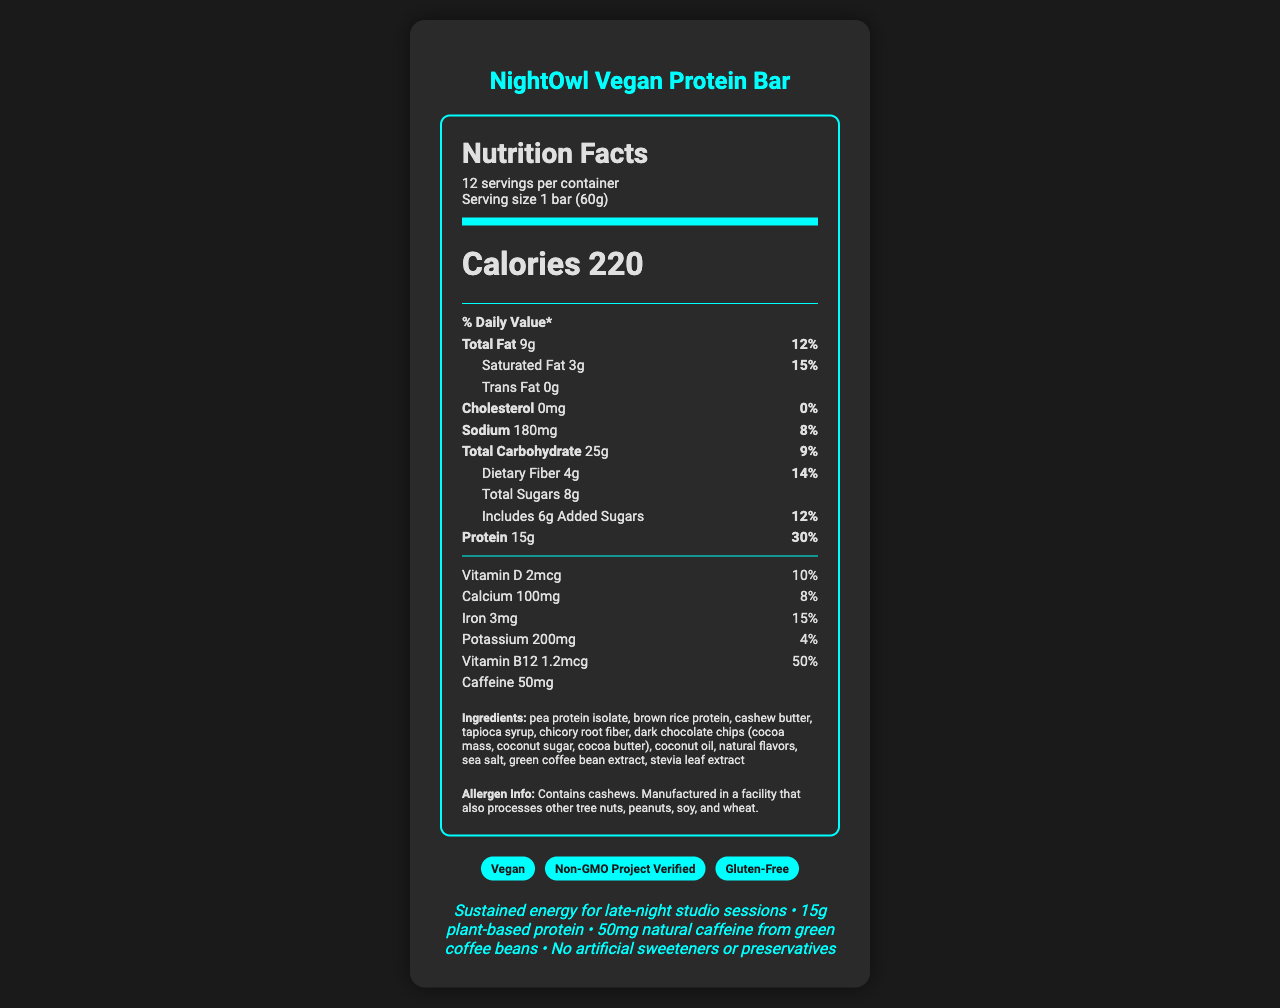what is the serving size of the NightOwl Vegan Protein Bar? The serving size information is located at the top of the nutrition facts label under the section titled "Serving size."
Answer: 1 bar (60g) how many servings are there per container? The label indicates “12 servings per container” near the top beneath the product name.
Answer: 12 how many grams of protein are in each bar? The protein content per serving is listed in the protein section of the nutrition facts with the amount “15g” and a daily value percentage of 30%.
Answer: 15g what is the daily value percentage of Vitamin B12 in each bar? You can find the daily value percentage of Vitamin B12 under its amount listed as “1.2mcg” and “50%”.
Answer: 50% which ingredient in the NightOwl Vegan Protein Bar provides natural caffeine? The ingredients list includes "green coffee bean extract" which is known to be a source of natural caffeine.
Answer: Green coffee bean extract how many calories are in one serving of the NightOwl Vegan Protein Bar? The calorie count is prominently displayed in large font under the header "Nutrition Facts" as “Calories 220”.
Answer: 220 what are the certifications of the NightOwl Vegan Protein Bar? A. USDA Organic, Non-GMO, Gluten-Free B. Vegan, Non-GMO Project Verified, Gluten-Free C. Vegan, Fair Trade, Gluten-Free D. Vegan, Non-GMO, USDA Organic The certifications are listed towards the bottom of the label in blue badges as "Vegan," "Non-GMO Project Verified," and "Gluten-Free".
Answer: B. Vegan, Non-GMO Project Verified, Gluten-Free what is the daily value percentage of saturated fat per serving? A. 10% B. 15% C. 20% D. 25% The daily value percentage for saturated fat is listed in the component section as “3g” with “15%” daily value.
Answer: B. 15% does the bar contain any artificial sweeteners or preservatives? One of the marketing claims says "No artificial sweeteners or preservatives."
Answer: No does the NightOwl Vegan Protein Bar contain any trans fat? The nutrition label states "Trans Fat 0g" indicating there is no trans fat in the product.
Answer: No what main allergens are noted in the document? This information is found under the allergen info section which states "Contains cashews. Manufactured in a facility that also processes other tree nuts, peanuts, soy, and wheat."
Answer: Cashews, other tree nuts, peanuts, soy, and wheat. summarize the main purpose and details of the NightOwl Vegan Protein Bar document. The summary captures the main idea of the document which is to inform potential consumers about the nutritional content, certifications, ingredients, and marketing benefits of the NightOwl Vegan Protein Bar.
Answer: The document provides comprehensive nutrition facts and information about the NightOwl Vegan Protein Bar, highlighting its vegan, non-GMO, and gluten-free certifications. It includes detailed nutrition content per serving, ingredient list, allergen information, and marketing claims emphasizing its benefits for late-night energy, protein content, and absence of artificial additives. what is the source of Vitamin D in the NightOwl Vegan Protein Bar? The document lists the amount and daily value percentage of Vitamin D but does not provide specific information about the source of Vitamin D.
Answer: Cannot be determined 